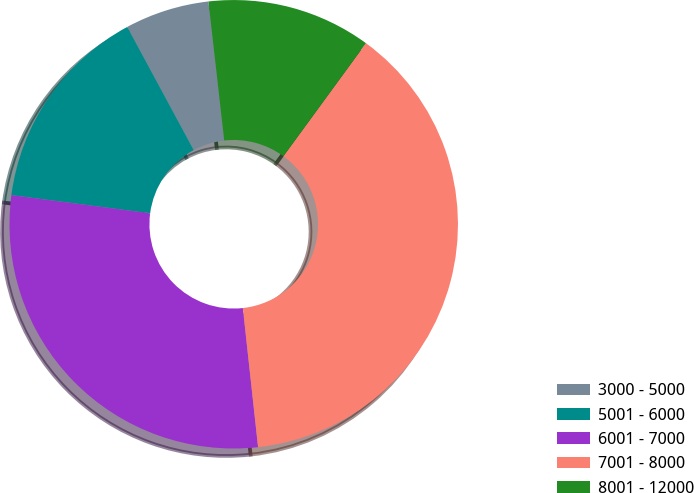Convert chart. <chart><loc_0><loc_0><loc_500><loc_500><pie_chart><fcel>3000 - 5000<fcel>5001 - 6000<fcel>6001 - 7000<fcel>7001 - 8000<fcel>8001 - 12000<nl><fcel>6.08%<fcel>15.05%<fcel>28.81%<fcel>38.23%<fcel>11.84%<nl></chart> 